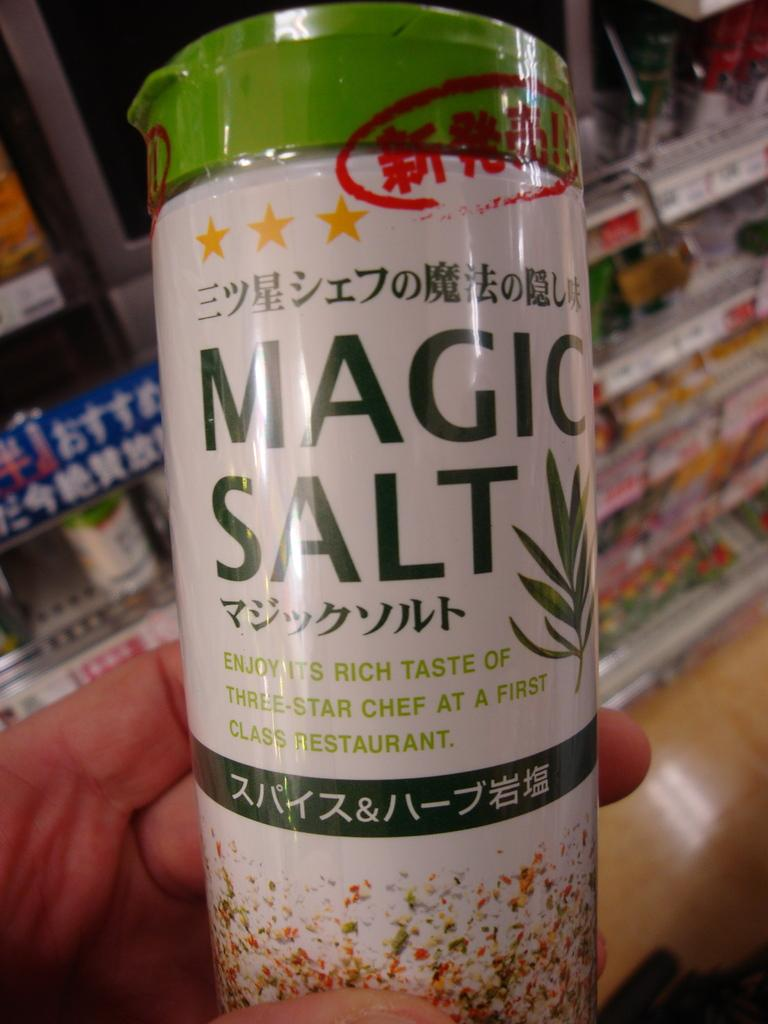Provide a one-sentence caption for the provided image. A UNSEALED BOTTLE OF MAGIC SALT WITH ORINTAL WRITTING. 